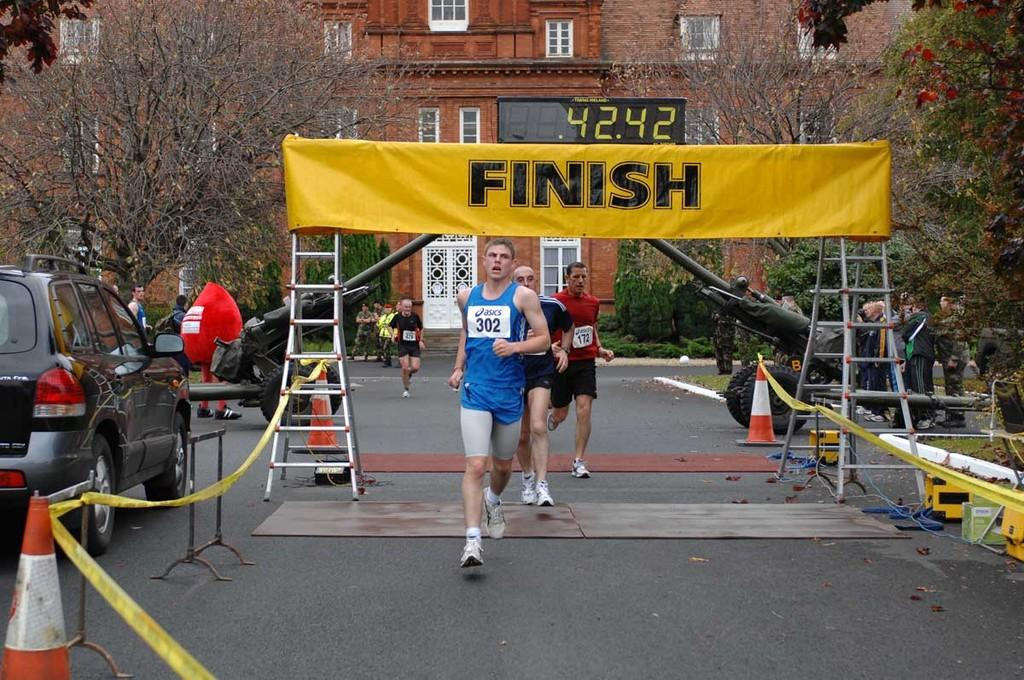<image>
Give a short and clear explanation of the subsequent image. the men are crossing the finish line of a race 